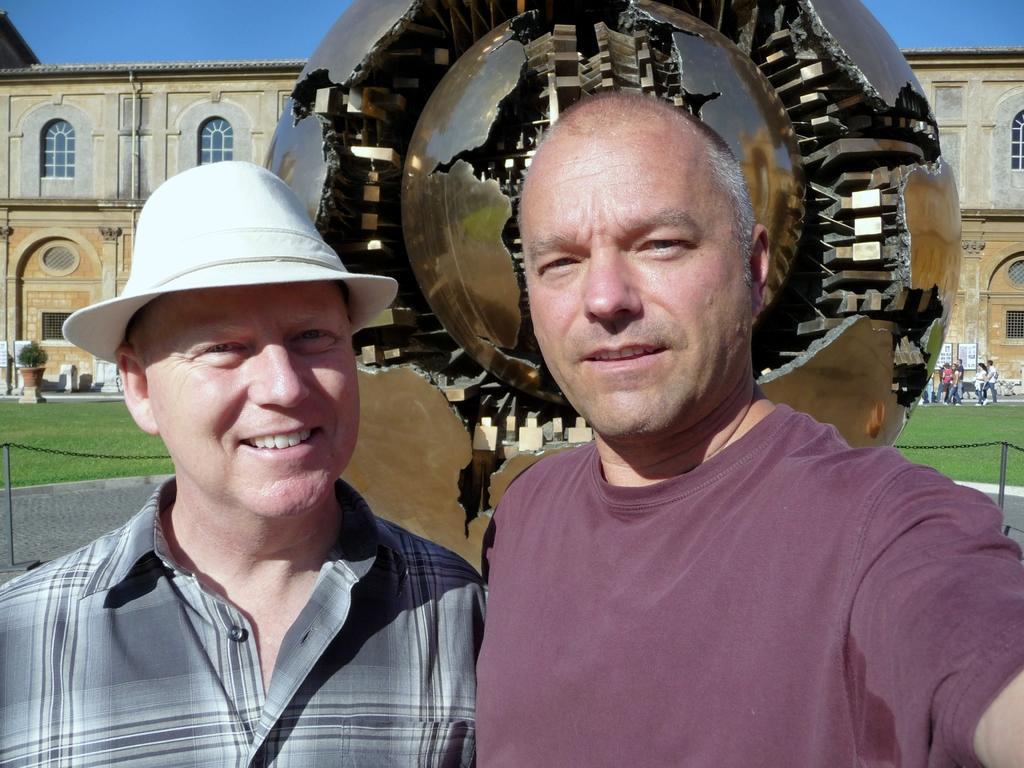Can you describe this image briefly? There are two persons standing at the bottom of this image and there is a steel object at the top of this image and there is a building in the background. There are some persons standing on the right side of this image and there is a plant on the left side of this image. 